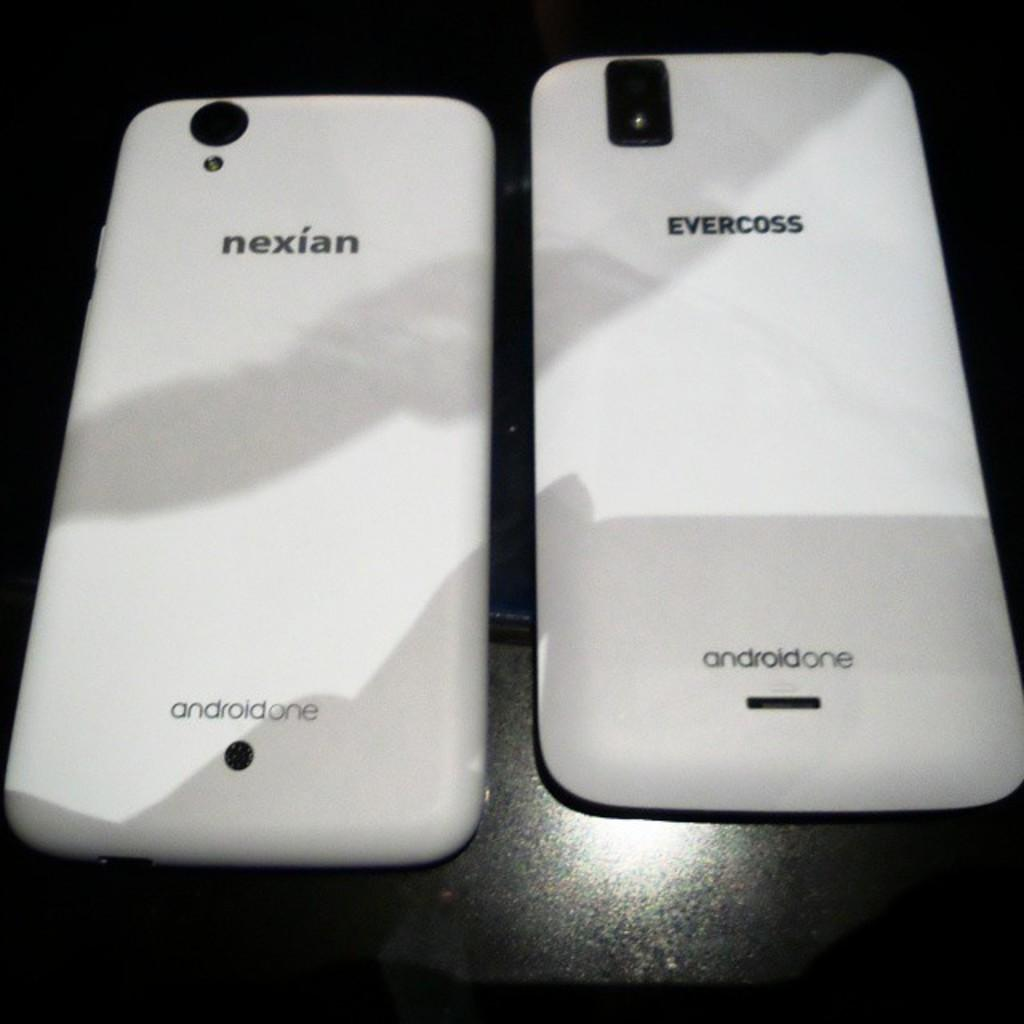<image>
Describe the image concisely. The cellphone on the left says nexian, the phone on the right says evercross. 